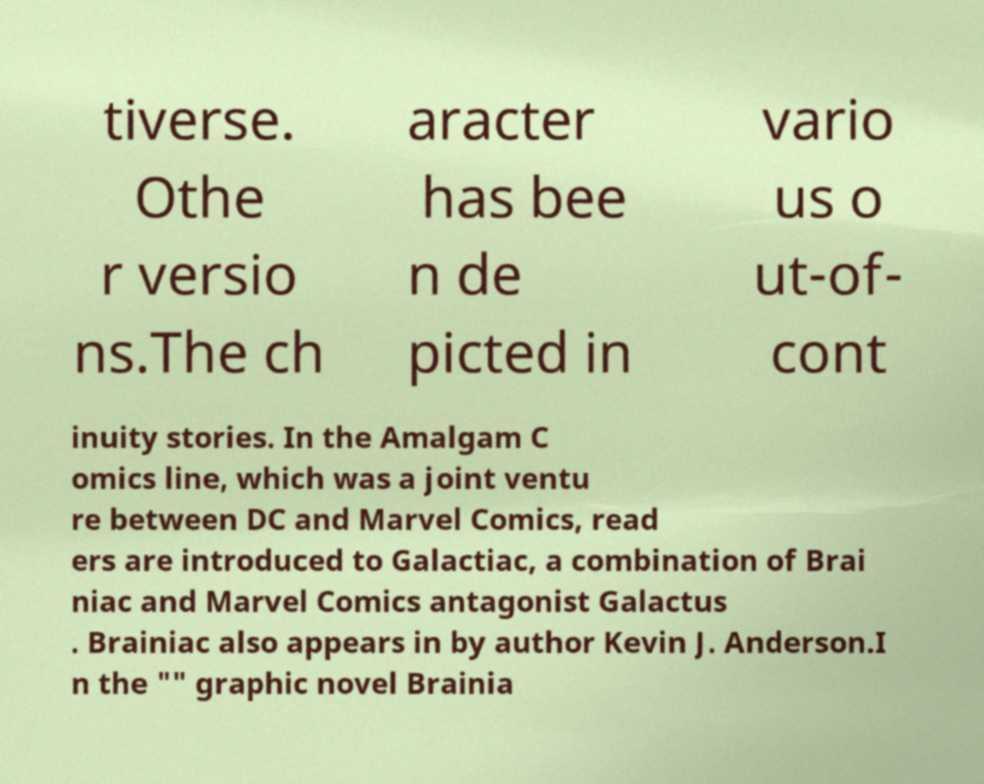What messages or text are displayed in this image? I need them in a readable, typed format. tiverse. Othe r versio ns.The ch aracter has bee n de picted in vario us o ut-of- cont inuity stories. In the Amalgam C omics line, which was a joint ventu re between DC and Marvel Comics, read ers are introduced to Galactiac, a combination of Brai niac and Marvel Comics antagonist Galactus . Brainiac also appears in by author Kevin J. Anderson.I n the "" graphic novel Brainia 